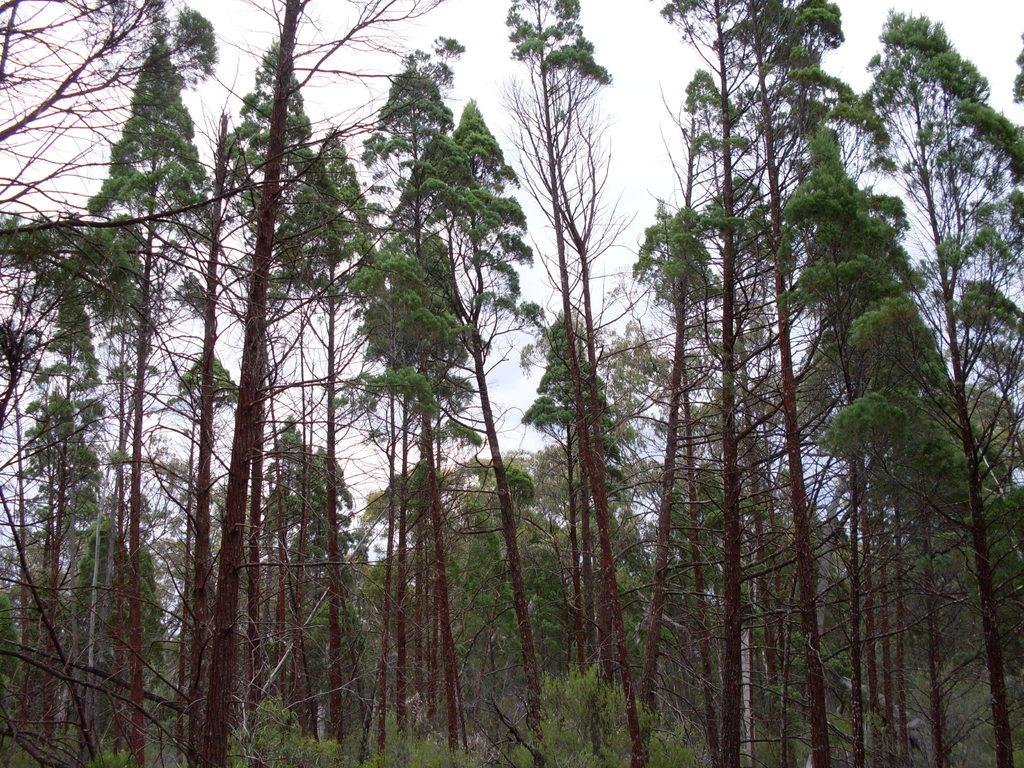What type of vegetation can be seen in the image? There are trees in the image. What part of the natural environment is visible in the image? The sky is visible in the background of the image. What type of jeans is your aunt wearing in the image? There is no aunt or jeans present in the image; it only features trees and the sky. 